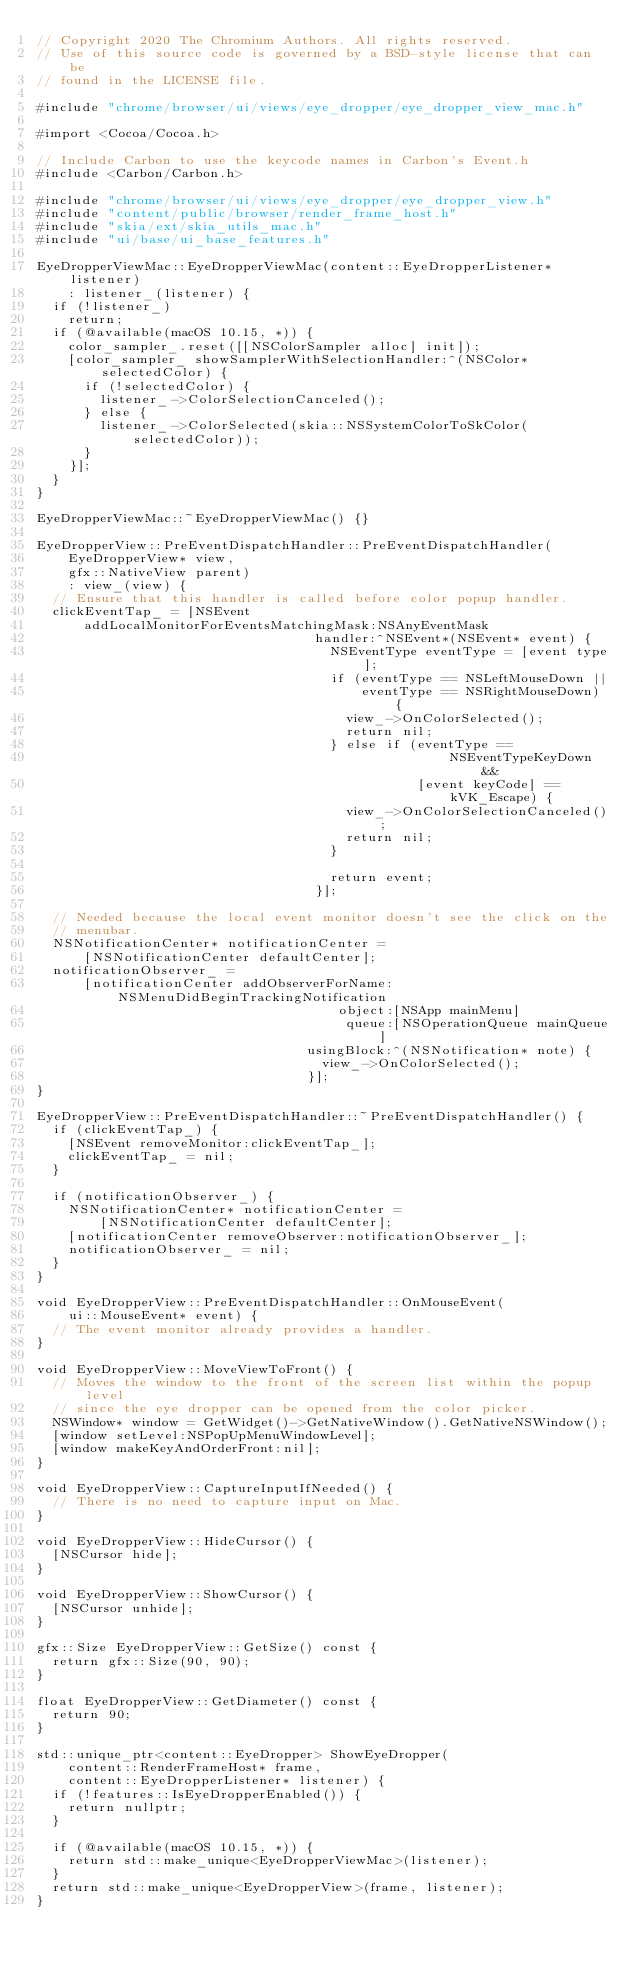Convert code to text. <code><loc_0><loc_0><loc_500><loc_500><_ObjectiveC_>// Copyright 2020 The Chromium Authors. All rights reserved.
// Use of this source code is governed by a BSD-style license that can be
// found in the LICENSE file.

#include "chrome/browser/ui/views/eye_dropper/eye_dropper_view_mac.h"

#import <Cocoa/Cocoa.h>

// Include Carbon to use the keycode names in Carbon's Event.h
#include <Carbon/Carbon.h>

#include "chrome/browser/ui/views/eye_dropper/eye_dropper_view.h"
#include "content/public/browser/render_frame_host.h"
#include "skia/ext/skia_utils_mac.h"
#include "ui/base/ui_base_features.h"

EyeDropperViewMac::EyeDropperViewMac(content::EyeDropperListener* listener)
    : listener_(listener) {
  if (!listener_)
    return;
  if (@available(macOS 10.15, *)) {
    color_sampler_.reset([[NSColorSampler alloc] init]);
    [color_sampler_ showSamplerWithSelectionHandler:^(NSColor* selectedColor) {
      if (!selectedColor) {
        listener_->ColorSelectionCanceled();
      } else {
        listener_->ColorSelected(skia::NSSystemColorToSkColor(selectedColor));
      }
    }];
  }
}

EyeDropperViewMac::~EyeDropperViewMac() {}

EyeDropperView::PreEventDispatchHandler::PreEventDispatchHandler(
    EyeDropperView* view,
    gfx::NativeView parent)
    : view_(view) {
  // Ensure that this handler is called before color popup handler.
  clickEventTap_ = [NSEvent
      addLocalMonitorForEventsMatchingMask:NSAnyEventMask
                                   handler:^NSEvent*(NSEvent* event) {
                                     NSEventType eventType = [event type];
                                     if (eventType == NSLeftMouseDown ||
                                         eventType == NSRightMouseDown) {
                                       view_->OnColorSelected();
                                       return nil;
                                     } else if (eventType ==
                                                    NSEventTypeKeyDown &&
                                                [event keyCode] == kVK_Escape) {
                                       view_->OnColorSelectionCanceled();
                                       return nil;
                                     }

                                     return event;
                                   }];

  // Needed because the local event monitor doesn't see the click on the
  // menubar.
  NSNotificationCenter* notificationCenter =
      [NSNotificationCenter defaultCenter];
  notificationObserver_ =
      [notificationCenter addObserverForName:NSMenuDidBeginTrackingNotification
                                      object:[NSApp mainMenu]
                                       queue:[NSOperationQueue mainQueue]
                                  usingBlock:^(NSNotification* note) {
                                    view_->OnColorSelected();
                                  }];
}

EyeDropperView::PreEventDispatchHandler::~PreEventDispatchHandler() {
  if (clickEventTap_) {
    [NSEvent removeMonitor:clickEventTap_];
    clickEventTap_ = nil;
  }

  if (notificationObserver_) {
    NSNotificationCenter* notificationCenter =
        [NSNotificationCenter defaultCenter];
    [notificationCenter removeObserver:notificationObserver_];
    notificationObserver_ = nil;
  }
}

void EyeDropperView::PreEventDispatchHandler::OnMouseEvent(
    ui::MouseEvent* event) {
  // The event monitor already provides a handler.
}

void EyeDropperView::MoveViewToFront() {
  // Moves the window to the front of the screen list within the popup level
  // since the eye dropper can be opened from the color picker.
  NSWindow* window = GetWidget()->GetNativeWindow().GetNativeNSWindow();
  [window setLevel:NSPopUpMenuWindowLevel];
  [window makeKeyAndOrderFront:nil];
}

void EyeDropperView::CaptureInputIfNeeded() {
  // There is no need to capture input on Mac.
}

void EyeDropperView::HideCursor() {
  [NSCursor hide];
}

void EyeDropperView::ShowCursor() {
  [NSCursor unhide];
}

gfx::Size EyeDropperView::GetSize() const {
  return gfx::Size(90, 90);
}

float EyeDropperView::GetDiameter() const {
  return 90;
}

std::unique_ptr<content::EyeDropper> ShowEyeDropper(
    content::RenderFrameHost* frame,
    content::EyeDropperListener* listener) {
  if (!features::IsEyeDropperEnabled()) {
    return nullptr;
  }

  if (@available(macOS 10.15, *)) {
    return std::make_unique<EyeDropperViewMac>(listener);
  }
  return std::make_unique<EyeDropperView>(frame, listener);
}
</code> 